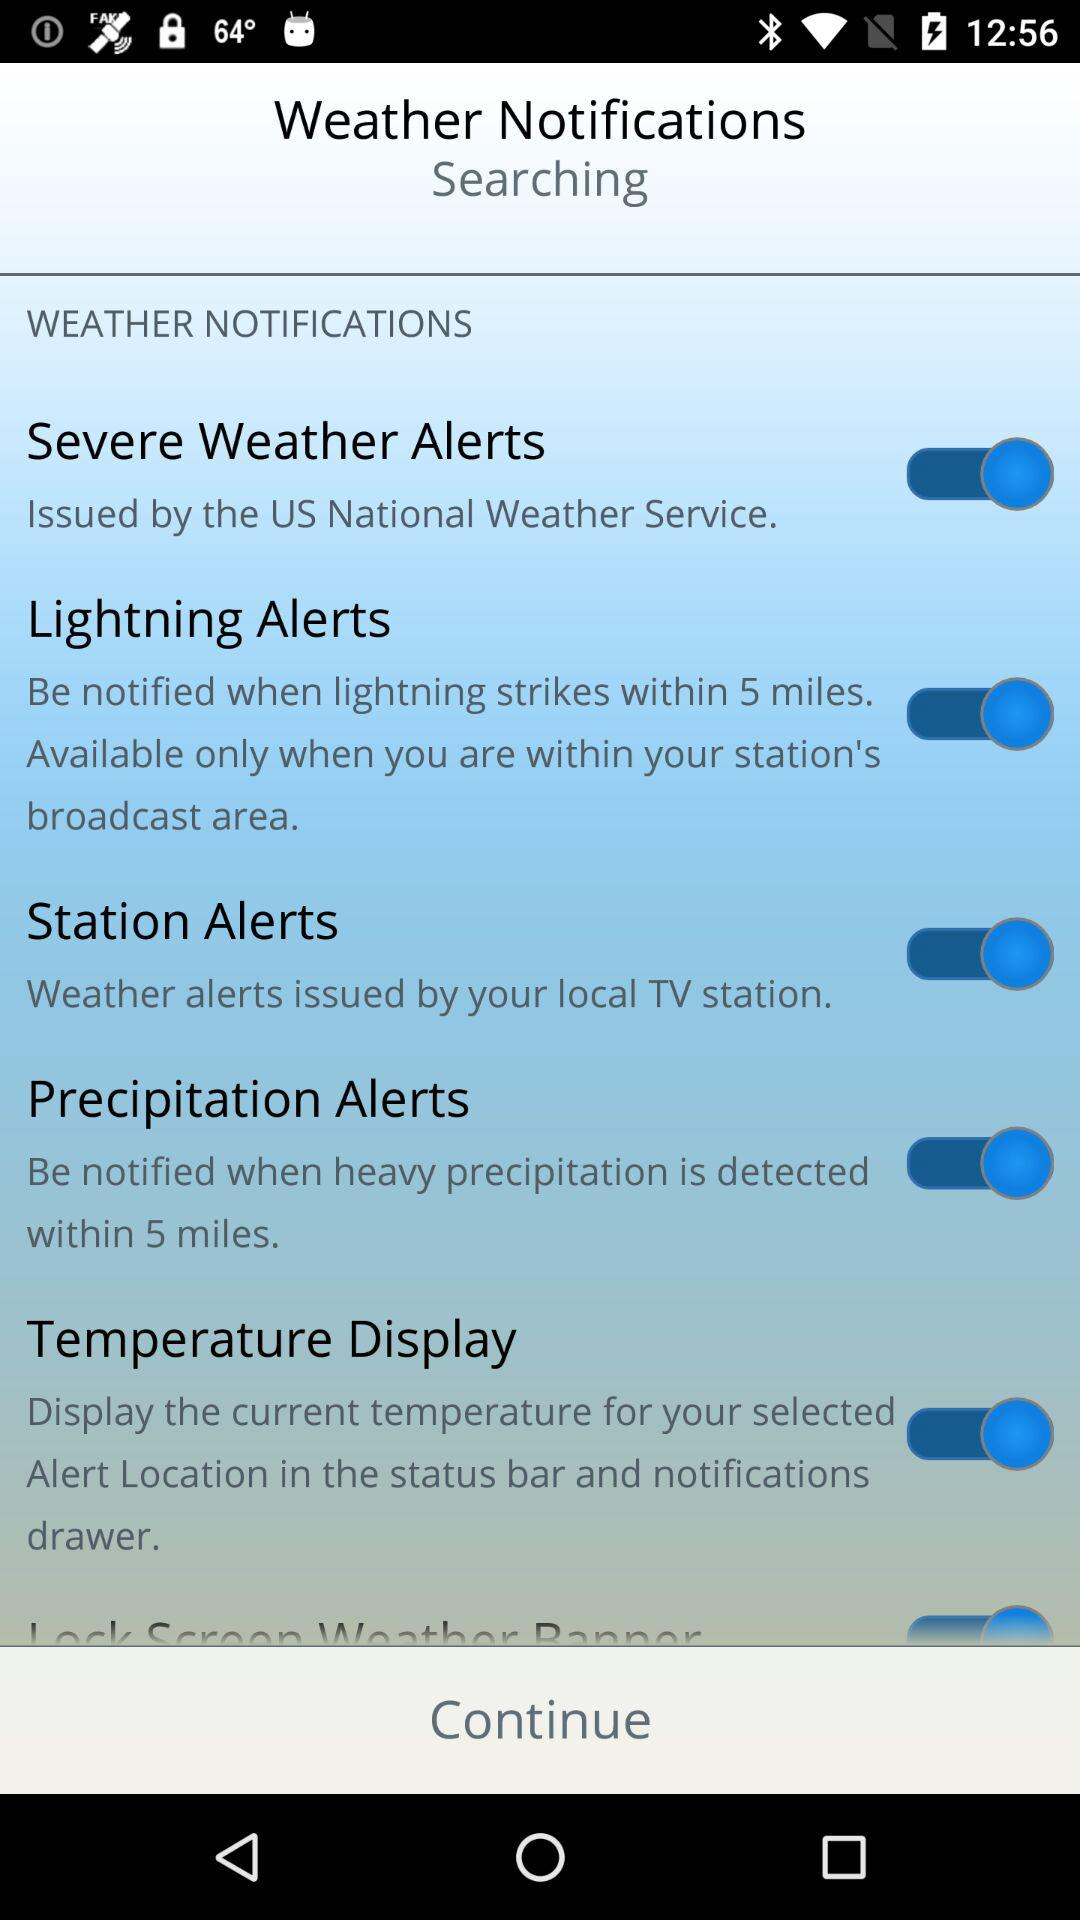Within how many miles will we be notified of the lightning strike? You will be notified when lightning strikes within 5 miles. 